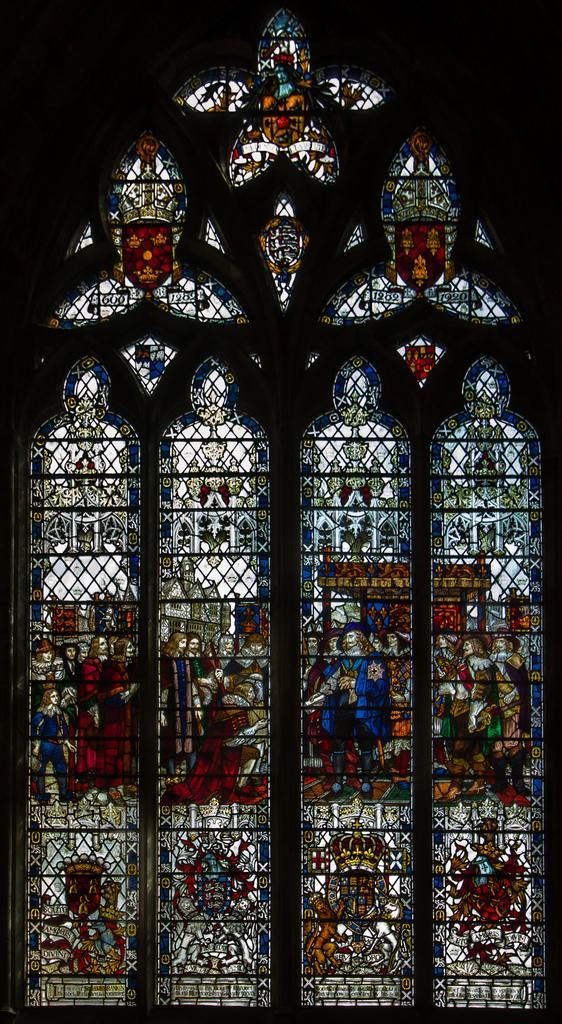Please provide a concise description of this image. In this image in the foreground there are windows, and we could see some art and there is a black background. 